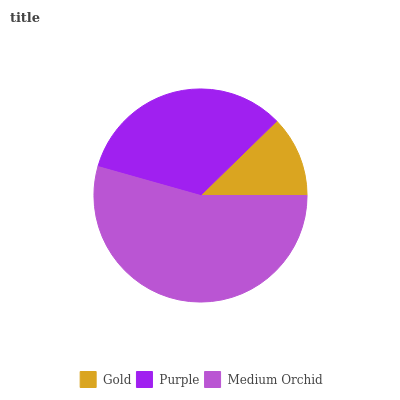Is Gold the minimum?
Answer yes or no. Yes. Is Medium Orchid the maximum?
Answer yes or no. Yes. Is Purple the minimum?
Answer yes or no. No. Is Purple the maximum?
Answer yes or no. No. Is Purple greater than Gold?
Answer yes or no. Yes. Is Gold less than Purple?
Answer yes or no. Yes. Is Gold greater than Purple?
Answer yes or no. No. Is Purple less than Gold?
Answer yes or no. No. Is Purple the high median?
Answer yes or no. Yes. Is Purple the low median?
Answer yes or no. Yes. Is Medium Orchid the high median?
Answer yes or no. No. Is Gold the low median?
Answer yes or no. No. 